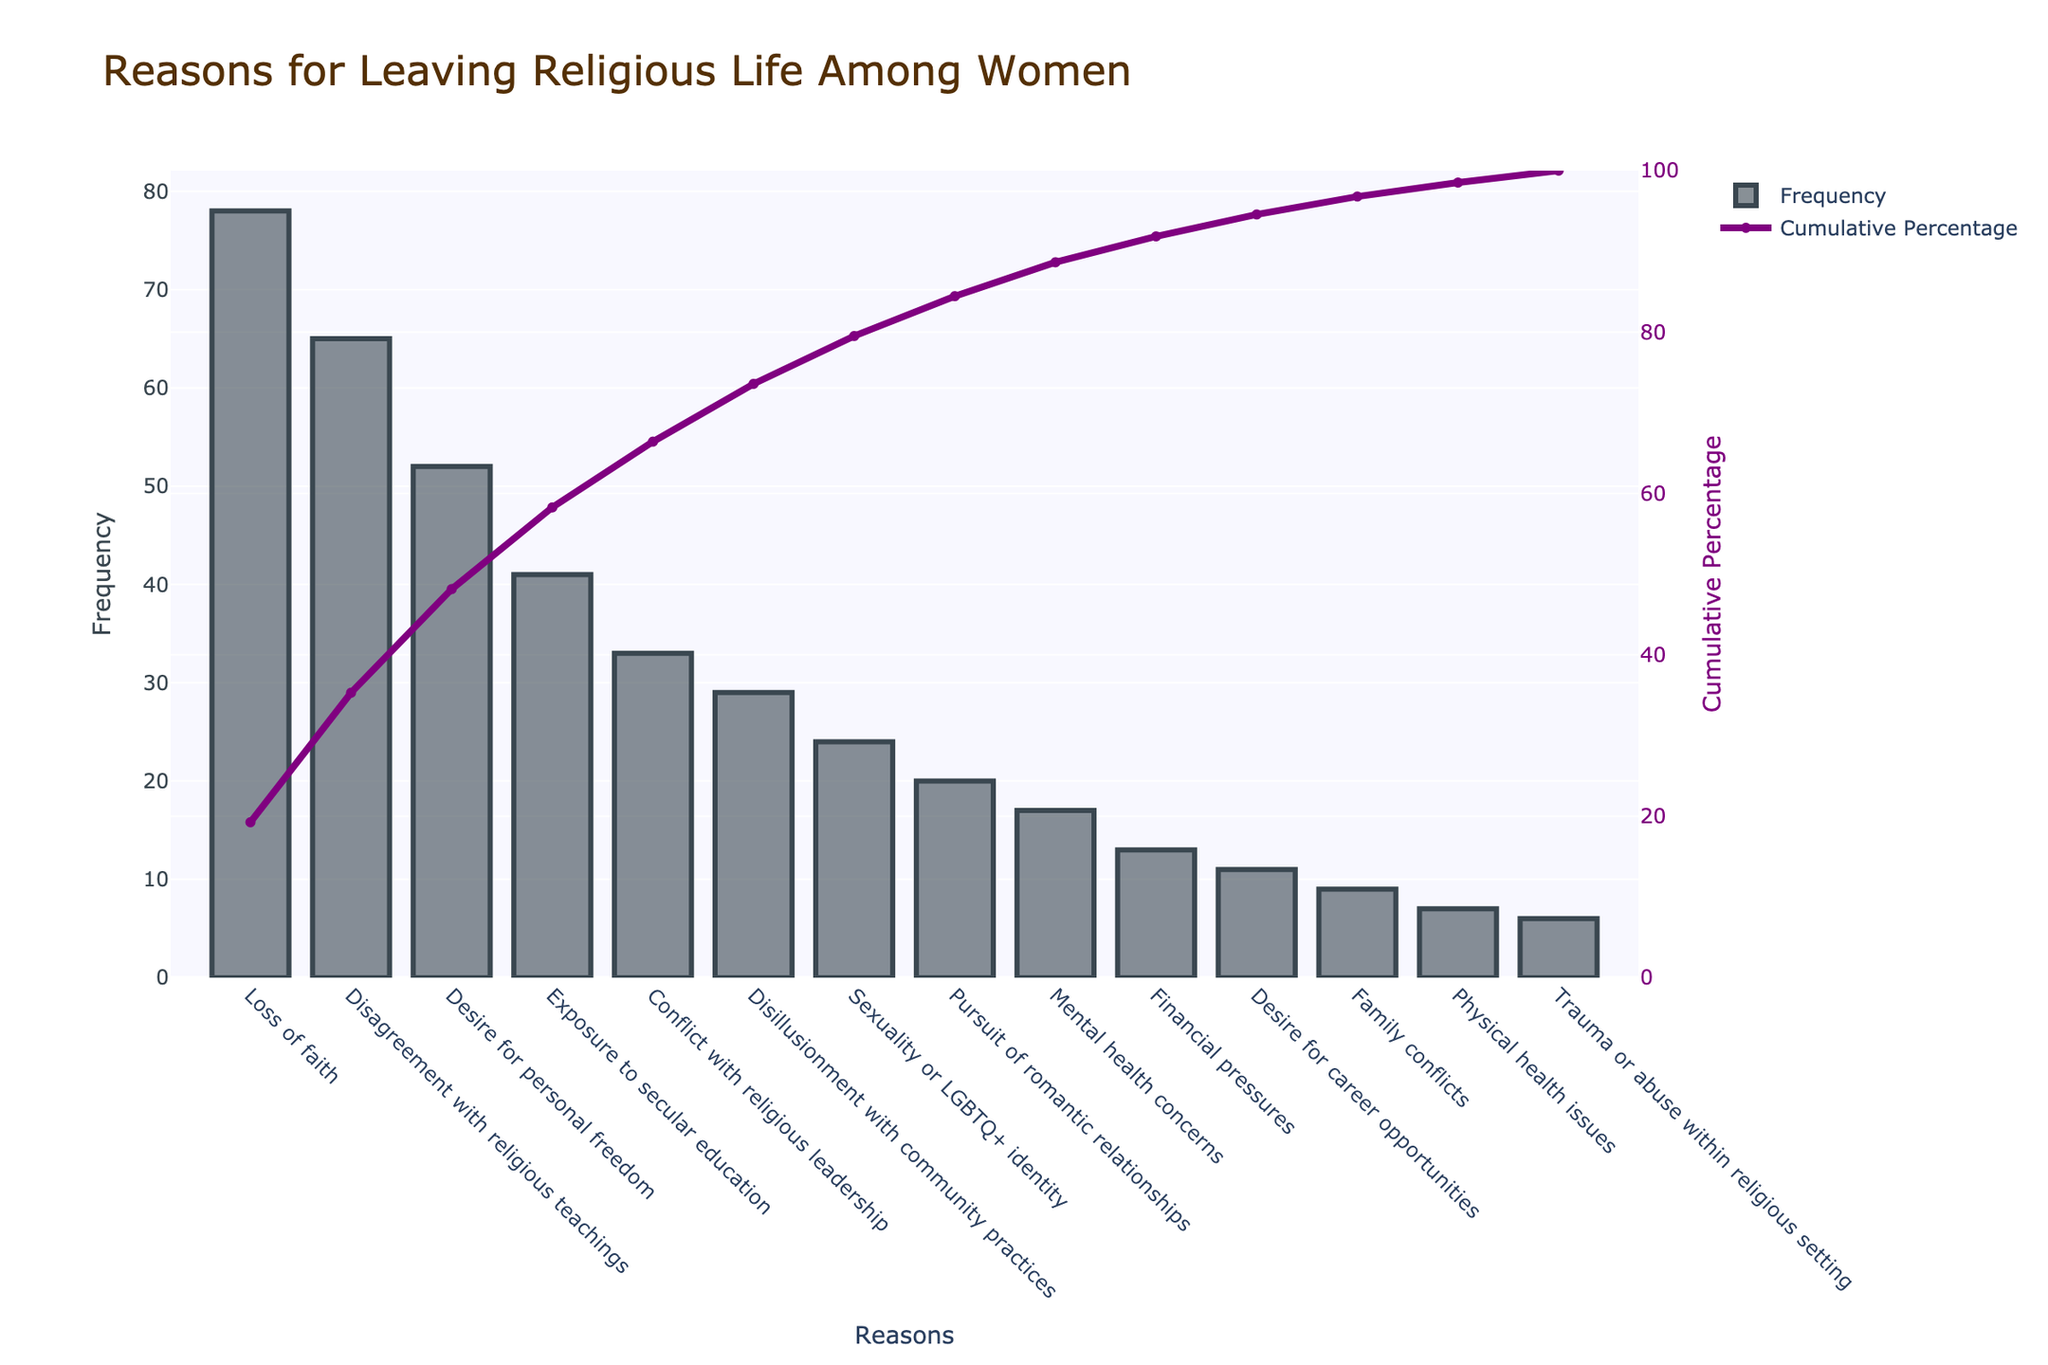What is the title of this chart? The title is positioned at the top of the figure, indicating the main subject of the visualization.
Answer: Reasons for Leaving Religious Life Among Women Which reason has the highest frequency? The bar with the greatest height represents the reason with the highest frequency.
Answer: Loss of faith What is the cumulative percentage for 'Exposure to secular education'? Locate 'Exposure to secular education' on the x-axis and check the corresponding point on the right y-axis for cumulative percentage.
Answer: Approximately 59% How many reasons have a frequency of 20 or above? Count the number of bars that have heights corresponding to a frequency of 20 or more.
Answer: Eight What is the cumulative percentage after adding 'Sexuality or LGBTQ+ identity'? Sum the frequencies up to and including 'Sexuality or LGBTQ+ identity' and then divide by the total frequency, converting it to a percentage.
Answer: Approximately 89% Which has a higher frequency: 'Conflict with religious leadership' or 'Disillusionment with community practices'? Compare the heights of the bars for 'Conflict with religious leadership' and 'Disillusionment with community practices'.
Answer: Conflict with religious leadership How does the frequency of 'Loss of faith' compare to 'Disagreement with religious teachings'? Calculate the difference in the heights of the bars representing these two reasons.
Answer: Loss of faith is higher by 13 How many reasons account for roughly 75% of the cumulative percentage? Find the point on the cumulative percentage line where it reaches 75% and count the number of bars up to that point.
Answer: Six What is the frequency of the reason with the lowest occurrence? Identify the shortest bar and read the frequency value.
Answer: 6 How much higher is the cumulative percentage for 'Desire for personal freedom' compared to 'Conflict with religious leadership'? Locate both reasons on the x-axis, find their corresponding cumulative percentages on the right y-axis, and calculate the difference.
Answer: Approximately 12% 